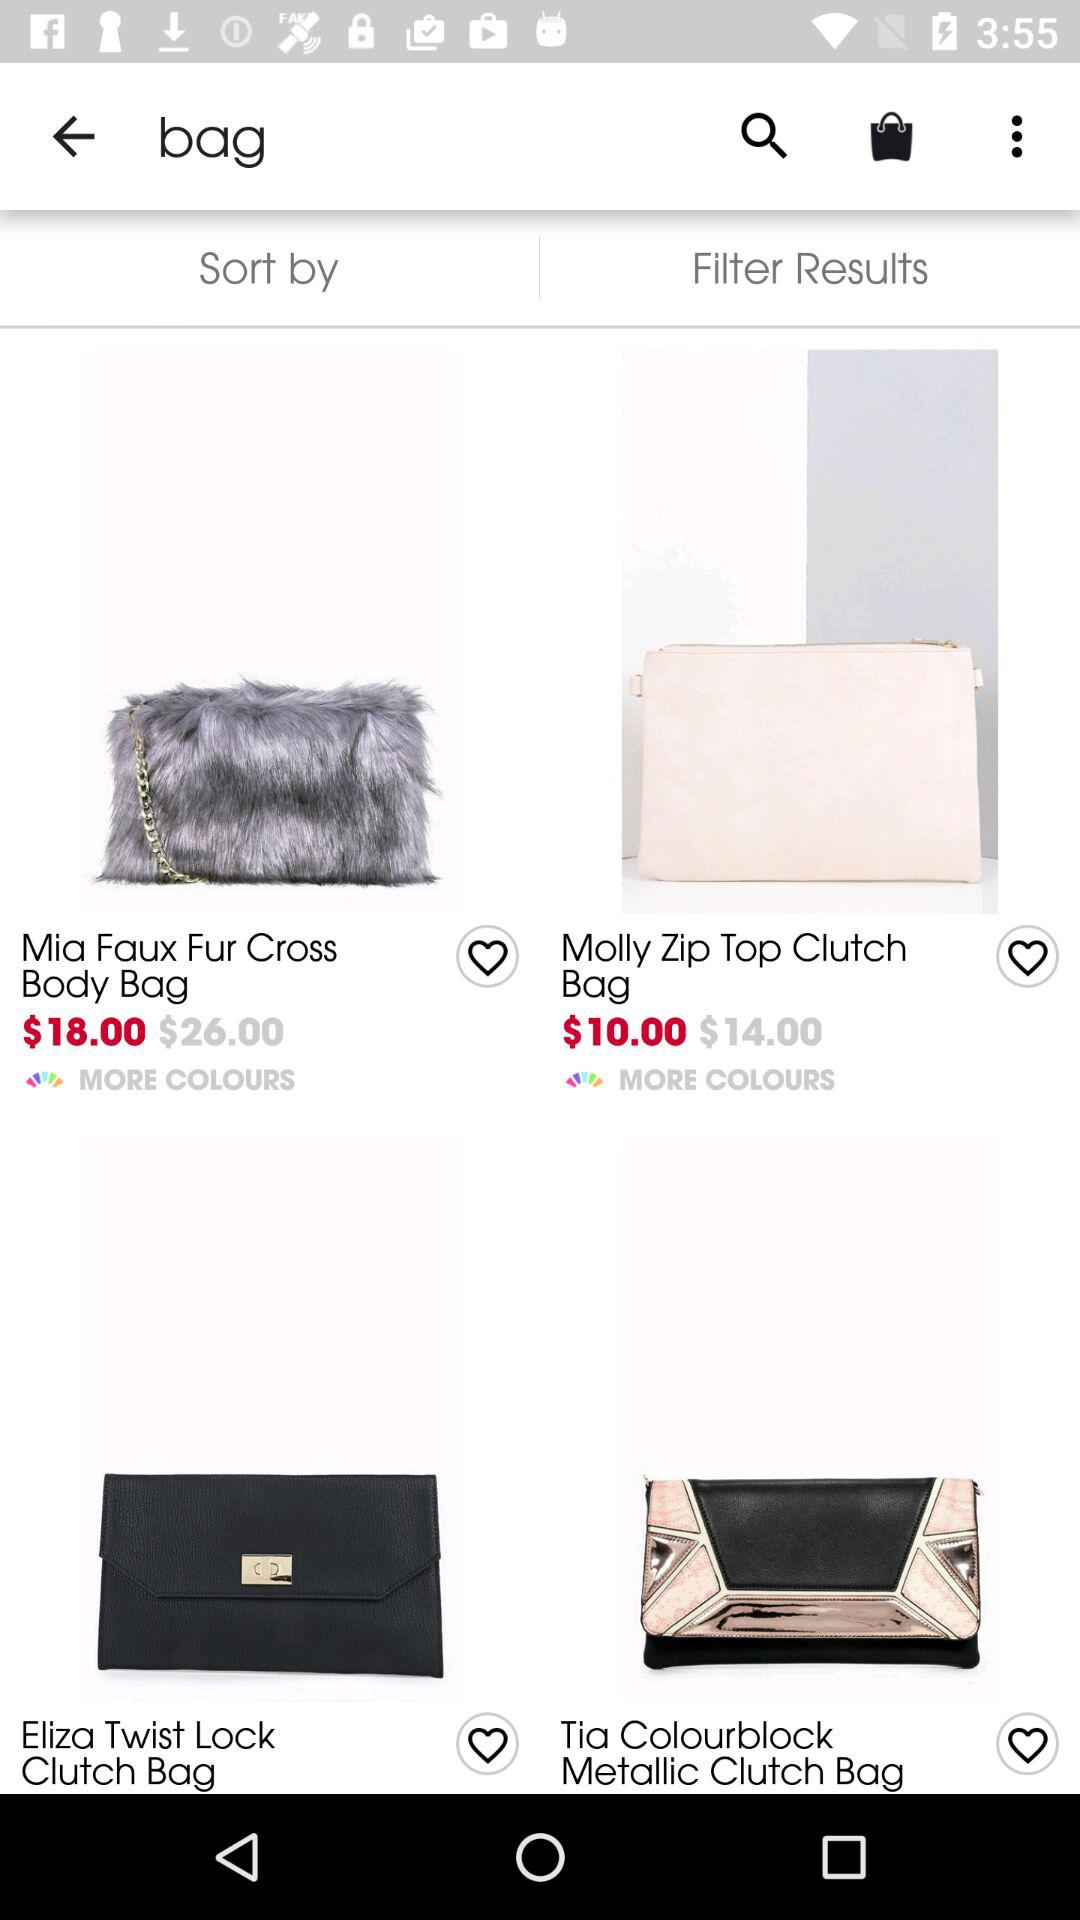What is the price of Mia faux fur cross body bag before the discount? The price is $26.00. 